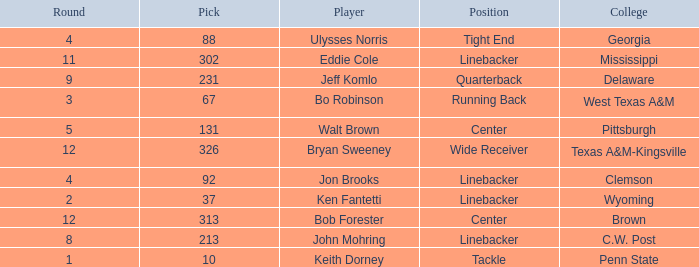What is the college pick for 213? C.W. Post. 